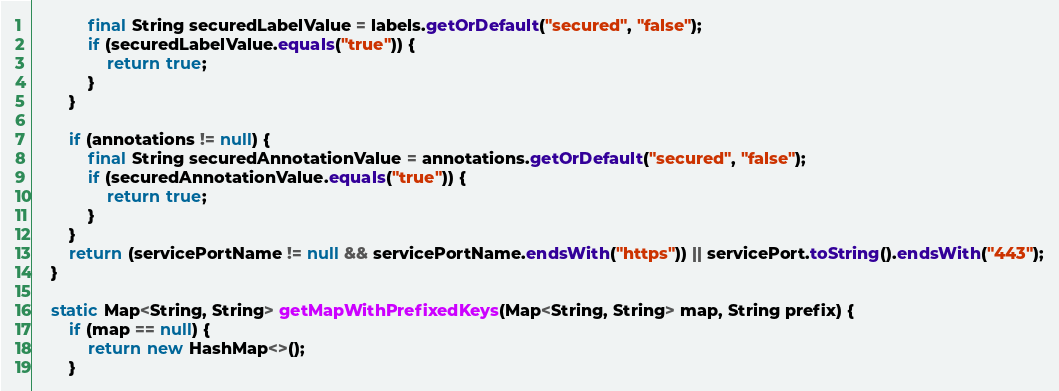<code> <loc_0><loc_0><loc_500><loc_500><_Java_>			final String securedLabelValue = labels.getOrDefault("secured", "false");
			if (securedLabelValue.equals("true")) {
				return true;
			}
		}

		if (annotations != null) {
			final String securedAnnotationValue = annotations.getOrDefault("secured", "false");
			if (securedAnnotationValue.equals("true")) {
				return true;
			}
		}
		return (servicePortName != null && servicePortName.endsWith("https")) || servicePort.toString().endsWith("443");
	}

	static Map<String, String> getMapWithPrefixedKeys(Map<String, String> map, String prefix) {
		if (map == null) {
			return new HashMap<>();
		}</code> 